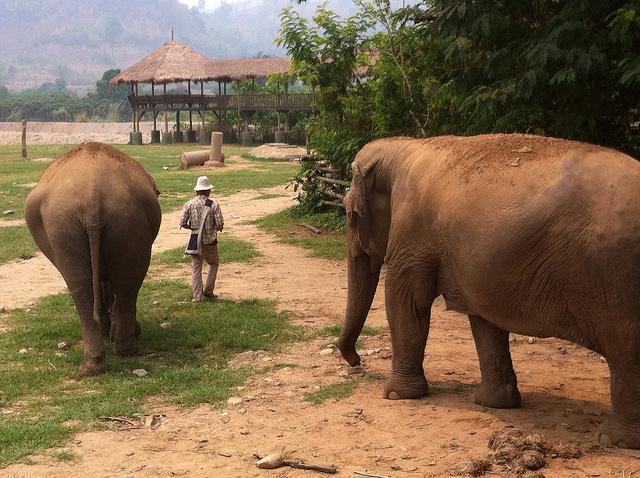How many elephants are following after the man wearing a white hat?
Make your selection and explain in format: 'Answer: answer
Rationale: rationale.'
Options: Three, four, two, five. Answer: two.
Rationale: A couple of elephants are following the man. What is between the elephants?
Choose the correct response and explain in the format: 'Answer: answer
Rationale: rationale.'
Options: Buzzard, box, bench, man. Answer: man.
Rationale: There is a person with two arms and legs who is wearing a hat. he is standing in between the two elephants. 